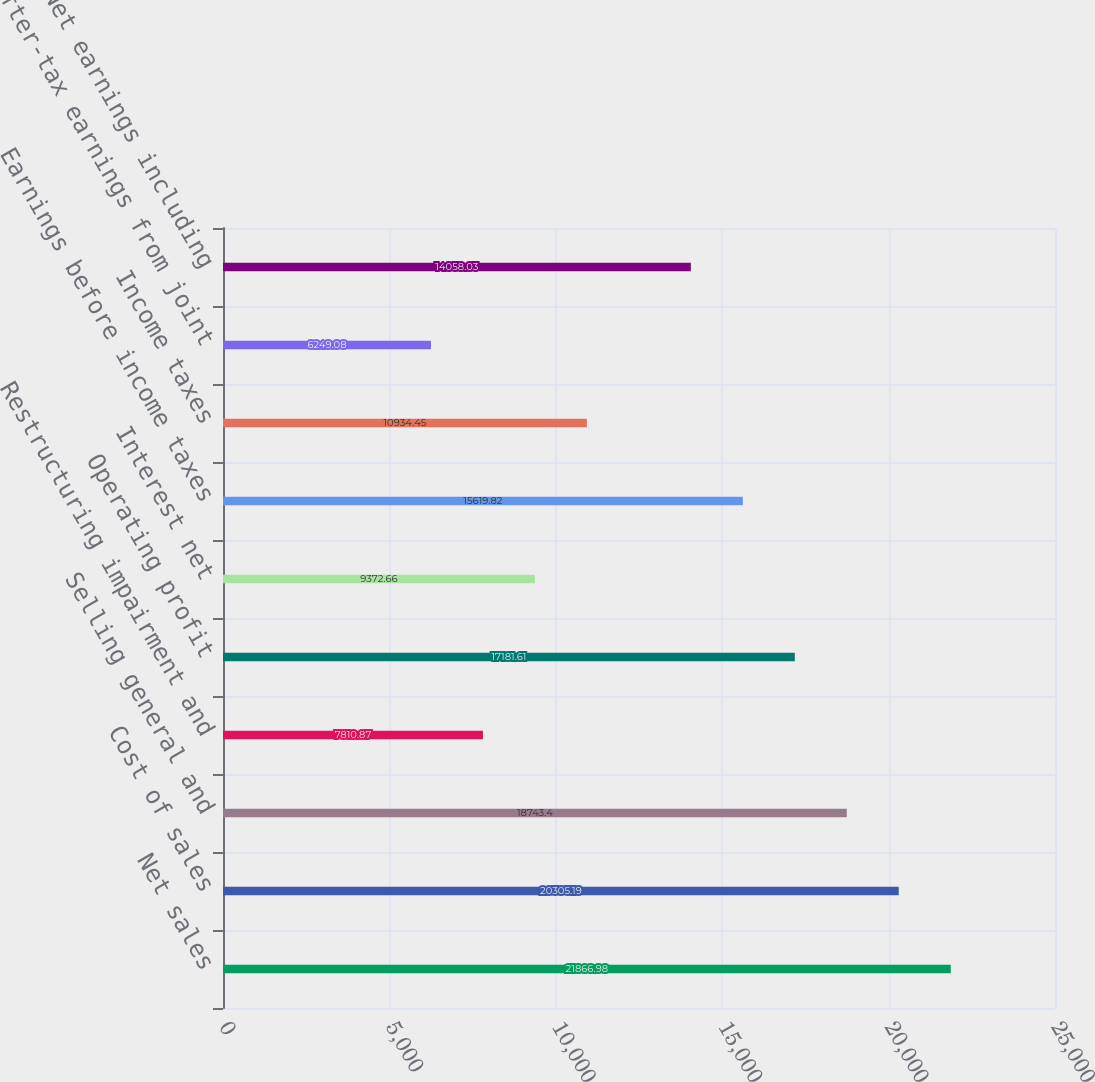<chart> <loc_0><loc_0><loc_500><loc_500><bar_chart><fcel>Net sales<fcel>Cost of sales<fcel>Selling general and<fcel>Restructuring impairment and<fcel>Operating profit<fcel>Interest net<fcel>Earnings before income taxes<fcel>Income taxes<fcel>After-tax earnings from joint<fcel>Net earnings including<nl><fcel>21867<fcel>20305.2<fcel>18743.4<fcel>7810.87<fcel>17181.6<fcel>9372.66<fcel>15619.8<fcel>10934.5<fcel>6249.08<fcel>14058<nl></chart> 